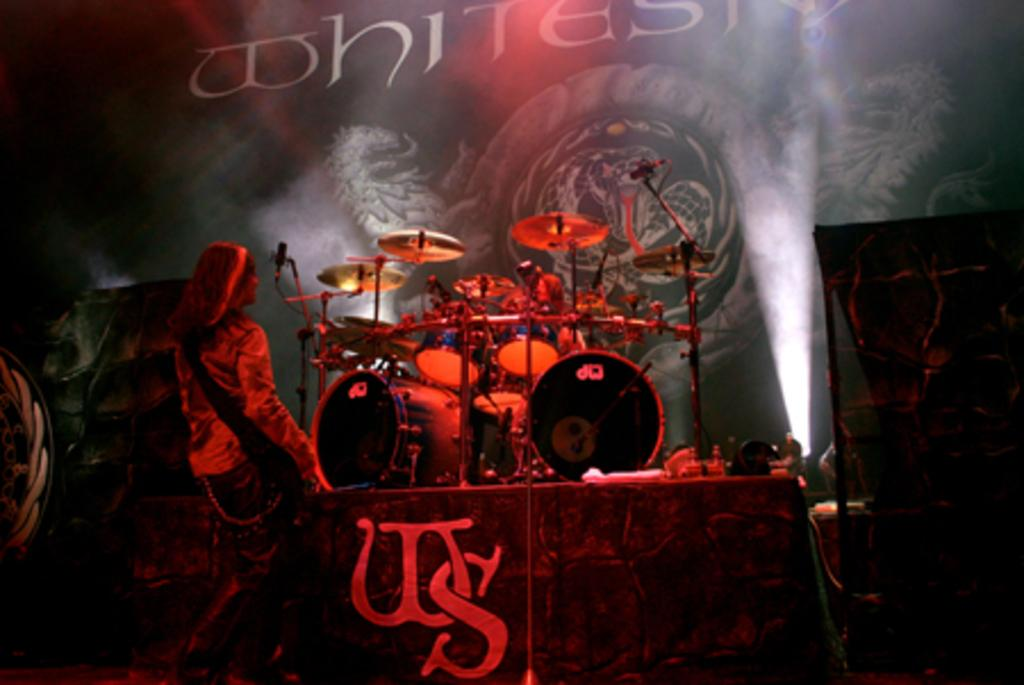What is the main subject of the image? There is a person standing in the image. Can you describe the person's appearance? The person is wearing clothes and is facing away from the camera. What other objects can be seen in the image? There are musical instruments, lights, microphones, a poster, and text on the poster in the image. What type of weather can be seen in the image? There is no weather visible in the image; it is an indoor setting with no reference to the outdoors. 